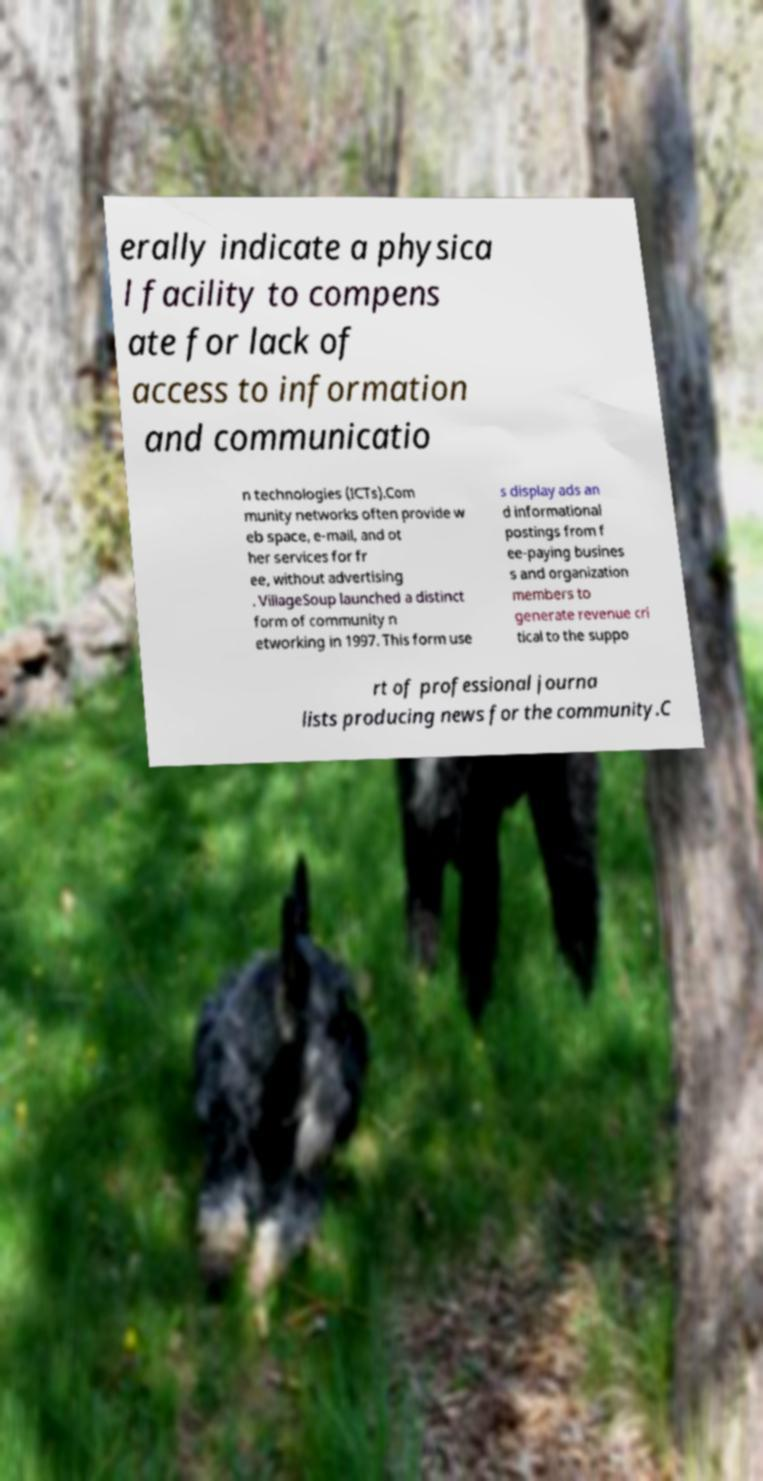What messages or text are displayed in this image? I need them in a readable, typed format. erally indicate a physica l facility to compens ate for lack of access to information and communicatio n technologies (ICTs).Com munity networks often provide w eb space, e-mail, and ot her services for fr ee, without advertising . VillageSoup launched a distinct form of community n etworking in 1997. This form use s display ads an d informational postings from f ee-paying busines s and organization members to generate revenue cri tical to the suppo rt of professional journa lists producing news for the community.C 